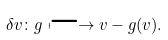Convert formula to latex. <formula><loc_0><loc_0><loc_500><loc_500>\delta v \colon g \longmapsto v - g ( v ) .</formula> 